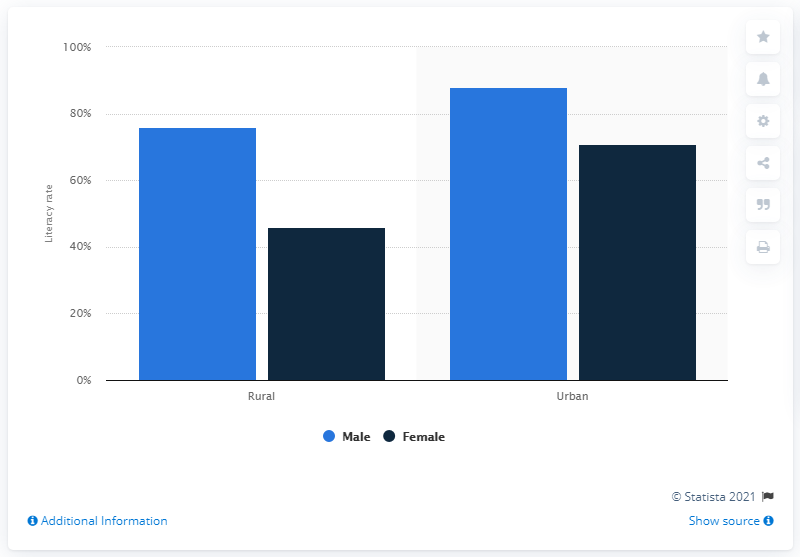Highlight a few significant elements in this photo. In 2011, the literacy rate among females living in rural areas in Rajasthan was 46%. 